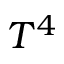Convert formula to latex. <formula><loc_0><loc_0><loc_500><loc_500>T ^ { 4 }</formula> 